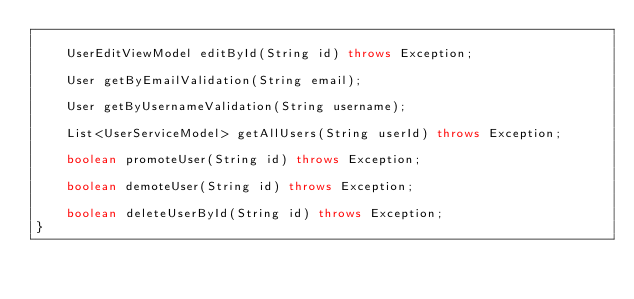Convert code to text. <code><loc_0><loc_0><loc_500><loc_500><_Java_>
    UserEditViewModel editById(String id) throws Exception;

    User getByEmailValidation(String email);

    User getByUsernameValidation(String username);

    List<UserServiceModel> getAllUsers(String userId) throws Exception;

    boolean promoteUser(String id) throws Exception;

    boolean demoteUser(String id) throws Exception;

    boolean deleteUserById(String id) throws Exception;
}
</code> 